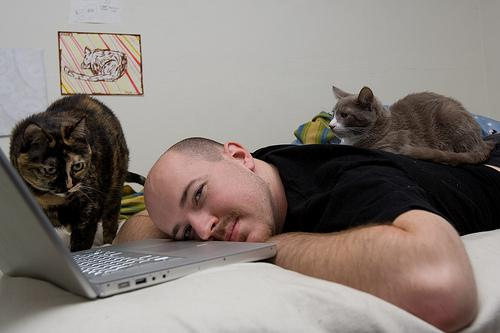Describe the interaction between the cats, the man and the laptop in the image. The man is lying down with one cat laying on his back and the other cat is standing on the bed looking at the laptop, implying curiosity and interaction among the man and the cats. Describe the quality of the image in terms of clarity and details. The image is of high quality with clear visibility of object details such as the man's facial features, cat body markings, and laptop design. How many cats can you see in the image and what are they doing? There are two cats, one is laying on the man's back while the other is standing on the bed and looking at the laptop. What objects can be found on the bed? A silver open laptop, a white comforter, a pillow, the man, and two cats. Mention everything you can infer about the man in the image. The man is laying on a bed, has a shaved head, is wearing a black shirt, resting his face on a laptop, and has a cat laying on his back. Describe the visible features of the gray and white cat. The grey cat has a white face and muzzle, furry grey ears, and looks comfortable. Count the total number of animals and humans present in the image. There are three individuals present in the image - one man and two cats. What elements are on the wall in the image? There are pictures on the wall, including a drawing of a cat with brown and pink stripes, and a picture with a colorful pattern. Provide an analysis of the image considering the man, cats, and different objects present. The image depicts a cozy and relaxing scene where the man is in comfortable clothing, laying down with one cat on his back and another cat on the bed. There is a sense of togetherness, communication, and human-animal interaction, as the cat standing on the bed is curiously observing the laptop, possibly due to human influence. Determine the emotional sentiment of the image. The emotional sentiment of the image is a mix of relaxation, comfort, and curiosity. 